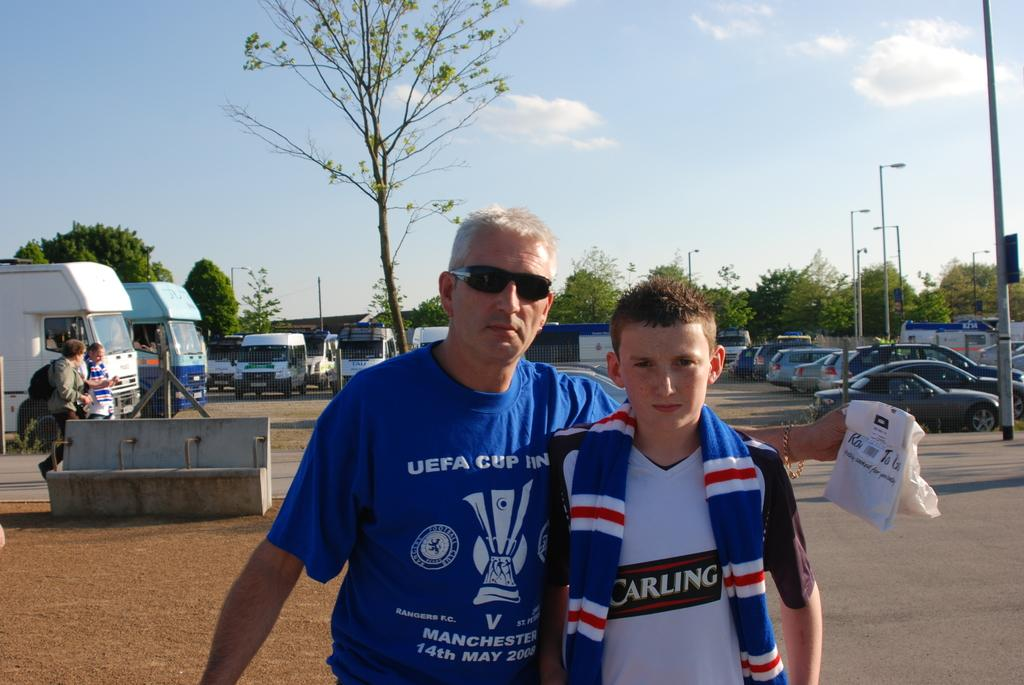<image>
Render a clear and concise summary of the photo. A boy is wearing a shirt with the word Carling on it. 